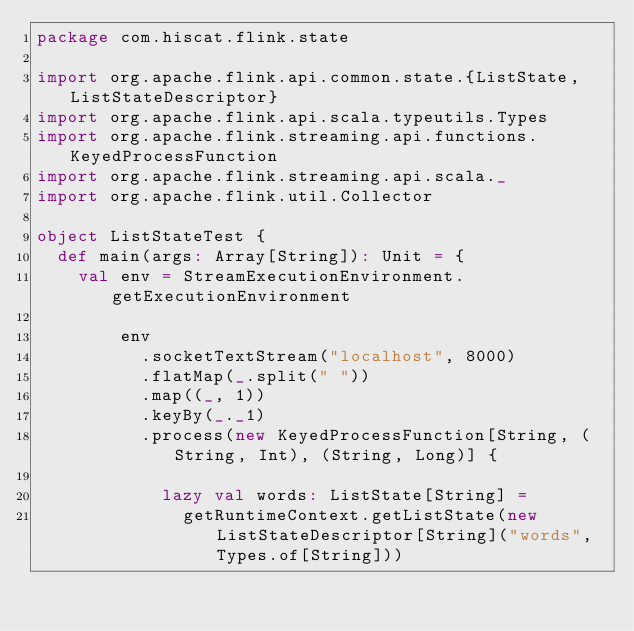<code> <loc_0><loc_0><loc_500><loc_500><_Scala_>package com.hiscat.flink.state

import org.apache.flink.api.common.state.{ListState, ListStateDescriptor}
import org.apache.flink.api.scala.typeutils.Types
import org.apache.flink.streaming.api.functions.KeyedProcessFunction
import org.apache.flink.streaming.api.scala._
import org.apache.flink.util.Collector

object ListStateTest {
  def main(args: Array[String]): Unit = {
    val env = StreamExecutionEnvironment.getExecutionEnvironment

        env
          .socketTextStream("localhost", 8000)
          .flatMap(_.split(" "))
          .map((_, 1))
          .keyBy(_._1)
          .process(new KeyedProcessFunction[String, (String, Int), (String, Long)] {

            lazy val words: ListState[String] =
              getRuntimeContext.getListState(new ListStateDescriptor[String]("words", Types.of[String]))
</code> 